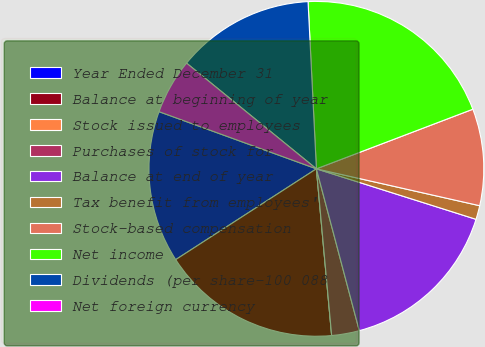Convert chart. <chart><loc_0><loc_0><loc_500><loc_500><pie_chart><fcel>Year Ended December 31<fcel>Balance at beginning of year<fcel>Stock issued to employees<fcel>Purchases of stock for<fcel>Balance at end of year<fcel>Tax benefit from employees'<fcel>Stock-based compensation<fcel>Net income<fcel>Dividends (per share-100 088<fcel>Net foreign currency<nl><fcel>14.67%<fcel>17.33%<fcel>0.0%<fcel>2.67%<fcel>16.0%<fcel>1.34%<fcel>9.33%<fcel>20.0%<fcel>13.33%<fcel>5.33%<nl></chart> 